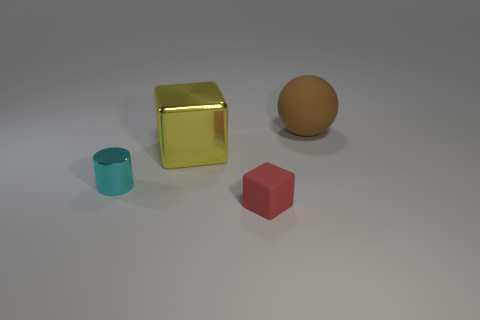Add 4 small green metallic spheres. How many objects exist? 8 Subtract all cylinders. How many objects are left? 3 Add 4 large metal blocks. How many large metal blocks are left? 5 Add 4 big green objects. How many big green objects exist? 4 Subtract 0 green cylinders. How many objects are left? 4 Subtract all large metal objects. Subtract all big objects. How many objects are left? 1 